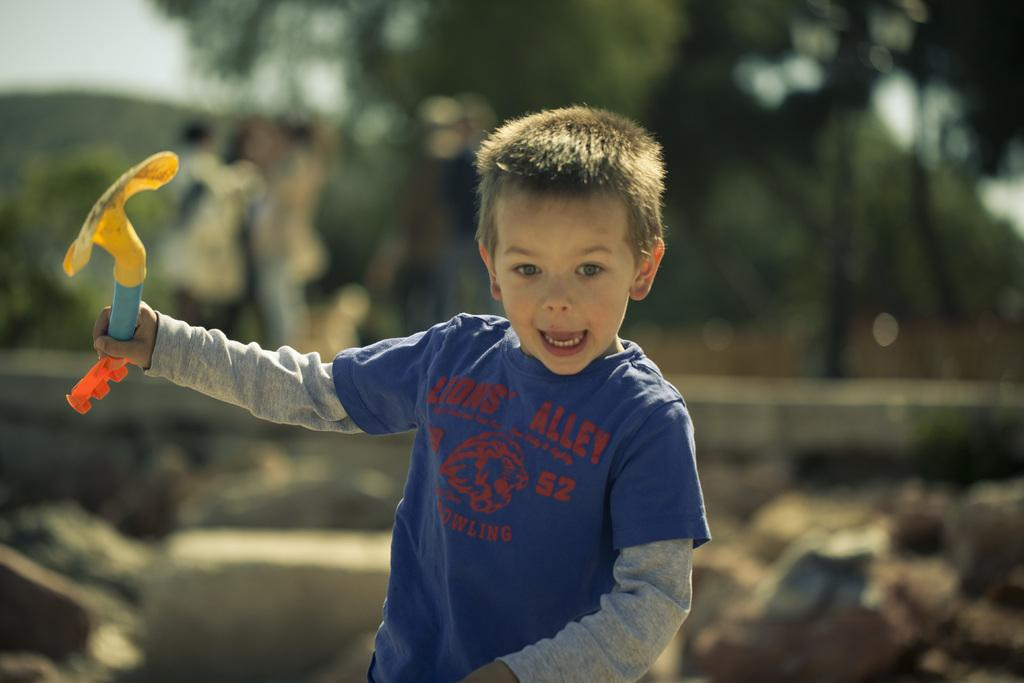What is the main subject of the image? The main subject of the image is a child. What can be observed about the child's attire? The child is wearing clothes. What is the child holding in their hand? The child is holding an object in their hand. Can you describe the background of the image? The background of the image is blurred. What type of distribution is the child participating in within the image? There is no indication of any distribution in the image; it simply features a child holding an object. Can you describe the child's kicking technique in the image? There is no kicking activity depicted in the image; the child is holding an object. 